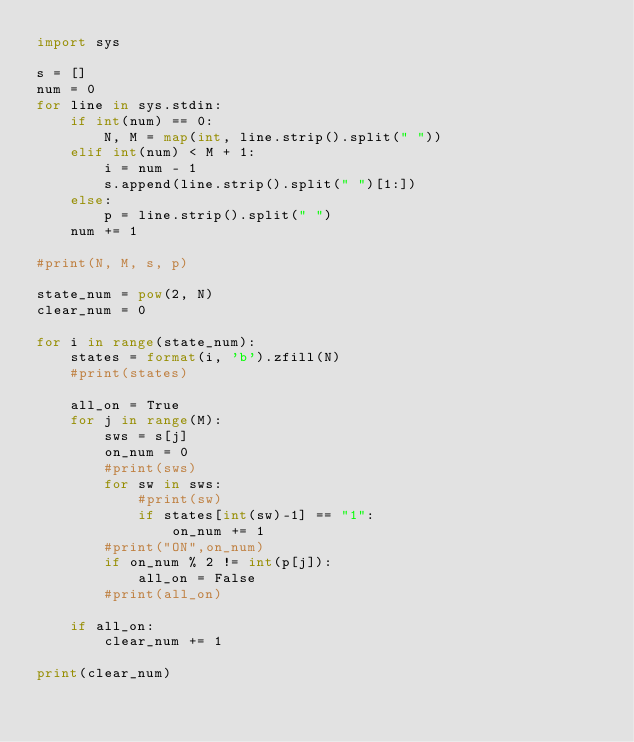Convert code to text. <code><loc_0><loc_0><loc_500><loc_500><_Python_>import sys

s = []
num = 0
for line in sys.stdin:
    if int(num) == 0:
        N, M = map(int, line.strip().split(" "))
    elif int(num) < M + 1:
        i = num - 1
        s.append(line.strip().split(" ")[1:])
    else:
        p = line.strip().split(" ")
    num += 1

#print(N, M, s, p)

state_num = pow(2, N)
clear_num = 0

for i in range(state_num):
    states = format(i, 'b').zfill(N)
    #print(states)

    all_on = True
    for j in range(M):
        sws = s[j]
        on_num = 0
        #print(sws)
        for sw in sws:
            #print(sw)
            if states[int(sw)-1] == "1":
                on_num += 1
        #print("ON",on_num)
        if on_num % 2 != int(p[j]):
            all_on = False
        #print(all_on)

    if all_on:
        clear_num += 1

print(clear_num)</code> 